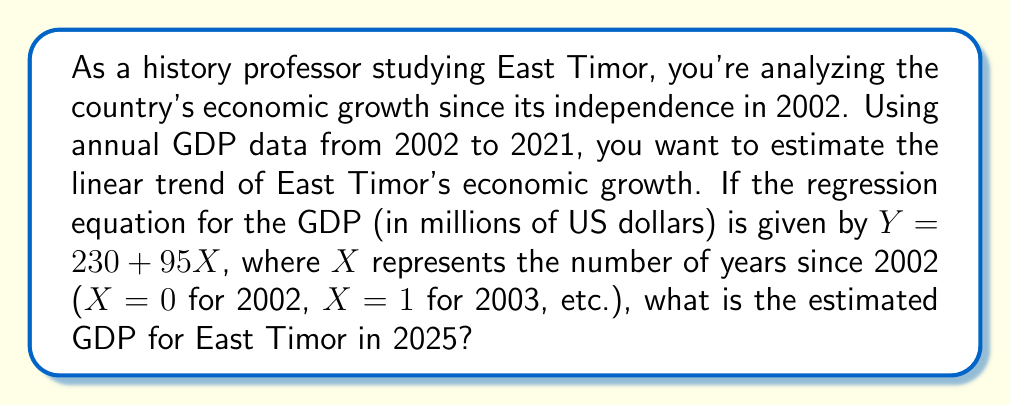Show me your answer to this math problem. To solve this problem, we need to use the given linear regression equation and determine the appropriate value for X. Let's break it down step-by-step:

1. The regression equation is given as:
   $$Y = 230 + 95X$$
   Where:
   - $Y$ is the estimated GDP in millions of US dollars
   - $X$ is the number of years since 2002

2. We need to find the value of X for the year 2025:
   - 2002 corresponds to X = 0
   - 2025 is 23 years after 2002, so X = 23

3. Now, we can substitute X = 23 into the equation:
   $$Y = 230 + 95(23)$$

4. Simplify the equation:
   $$Y = 230 + 2185$$
   $$Y = 2415$$

Therefore, the estimated GDP for East Timor in 2025 is 2,415 million US dollars.
Answer: $2,415 million 